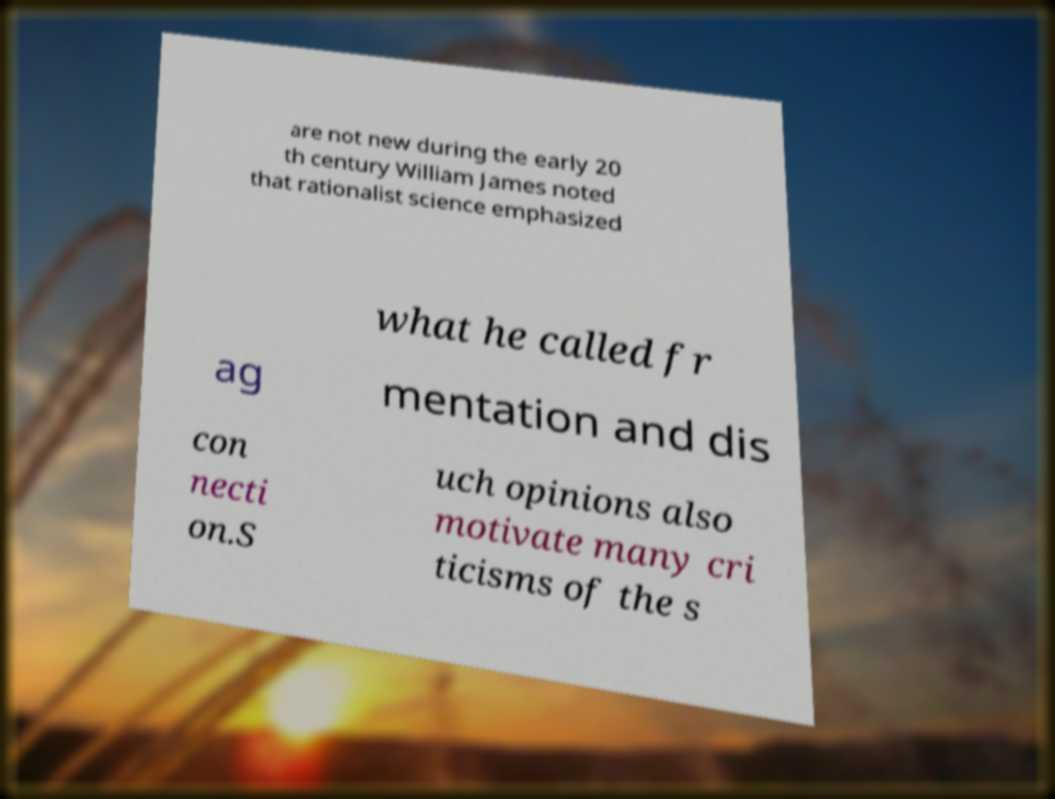Can you accurately transcribe the text from the provided image for me? are not new during the early 20 th century William James noted that rationalist science emphasized what he called fr ag mentation and dis con necti on.S uch opinions also motivate many cri ticisms of the s 